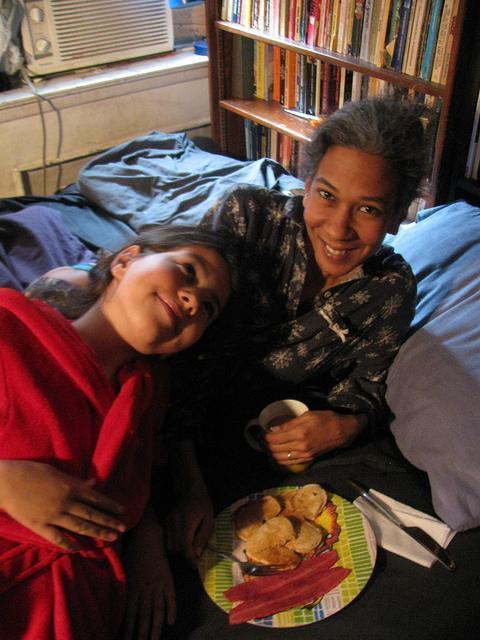How many people are in the image?
Give a very brief answer. 2. How many beds are visible?
Give a very brief answer. 1. How many books are there?
Give a very brief answer. 2. How many people are there?
Give a very brief answer. 2. 